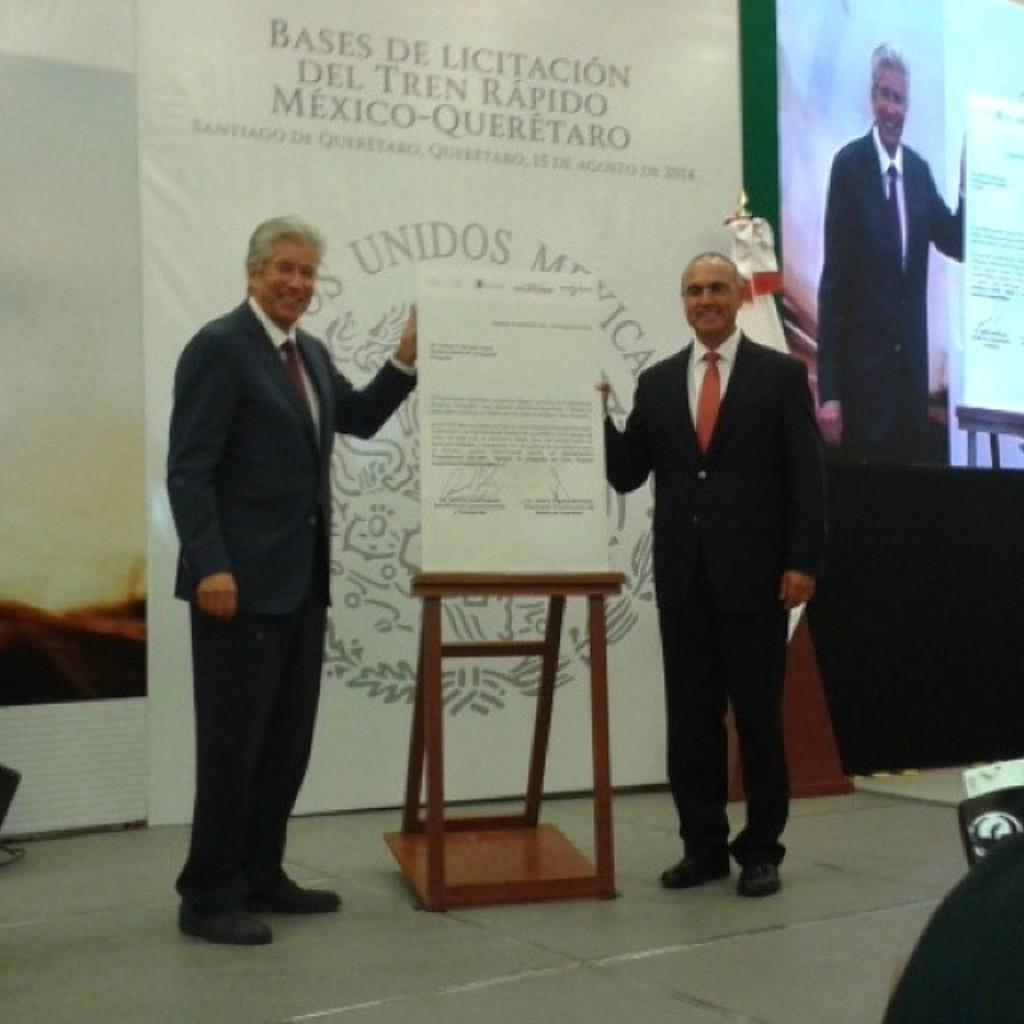Could you give a brief overview of what you see in this image? In this image I can see two men are standing and holding a paper. In the background I can see a screen and a banner. I can also see smile on their faces. 